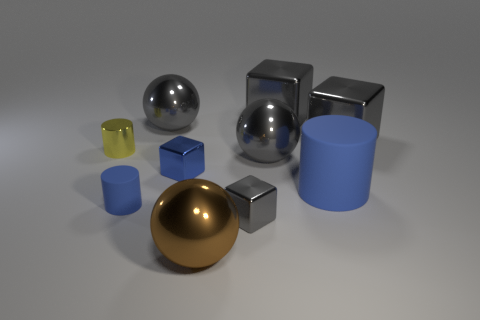There is a small cube that is the same color as the big matte thing; what material is it?
Keep it short and to the point. Metal. Are the tiny gray cube and the gray sphere that is right of the large brown thing made of the same material?
Provide a succinct answer. Yes. Are there any other matte cylinders that have the same color as the big cylinder?
Your response must be concise. Yes. How many other objects are the same material as the big blue cylinder?
Your answer should be very brief. 1. There is a tiny shiny cylinder; is it the same color as the tiny metal thing to the right of the tiny blue block?
Your response must be concise. No. Are there more cylinders behind the tiny matte object than brown things?
Keep it short and to the point. Yes. There is a large thing that is in front of the blue matte object that is to the left of the large matte thing; how many small yellow shiny objects are in front of it?
Make the answer very short. 0. There is a large metal thing in front of the tiny blue rubber cylinder; is it the same shape as the small blue matte object?
Keep it short and to the point. No. There is a large gray ball that is behind the yellow shiny thing; what material is it?
Ensure brevity in your answer.  Metal. There is a object that is both on the left side of the tiny gray metallic cube and right of the tiny blue block; what is its shape?
Give a very brief answer. Sphere. 